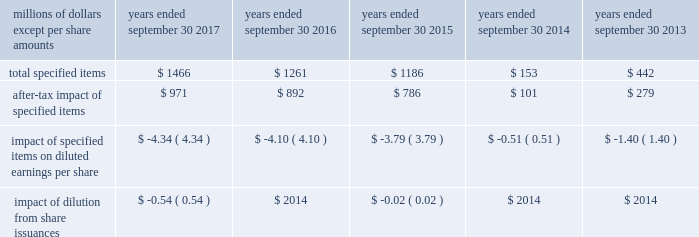( a ) excludes discontinued operations .
( b ) earnings before interest expense and taxes as a percent of average total assets .
( c ) total debt as a percent of the sum of total debt , shareholders 2019 equity and non-current deferred income tax liabilities .
The results above include the impact of the specified items detailed below .
Additional discussion regarding the specified items in fiscal years 2017 , 2016 and 2015 are provided in item 7 .
Management 2019s discussion and analysis of financial condition and results of operations. .
Item 7 .
Management 2019s discussion and analysis of financial condition and results of operations the following commentary should be read in conjunction with the consolidated financial statements and accompanying notes .
Within the tables presented throughout this discussion , certain columns may not add due to the use of rounded numbers for disclosure purposes .
Percentages and earnings per share amounts presented are calculated from the underlying amounts .
References to years throughout this discussion relate to our fiscal years , which end on september 30 .
Company overview description of the company and business segments becton , dickinson and company ( 201cbd 201d ) is a global medical technology company engaged in the development , manufacture and sale of a broad range of medical supplies , devices , laboratory equipment and diagnostic products used by healthcare institutions , life science researchers , clinical laboratories , the pharmaceutical industry and the general public .
The company's organizational structure is based upon two principal business segments , bd medical ( 201cmedical 201d ) and bd life sciences ( 201clife sciences 201d ) .
Bd 2019s products are manufactured and sold worldwide .
Our products are marketed in the united states and internationally through independent distribution channels and directly to end-users by bd and independent sales representatives .
We organize our operations outside the united states as follows : europe ; ema ( which includes the commonwealth of independent states , the middle east and africa ) ; greater asia ( which includes japan and asia pacific ) ; latin america ( which includes mexico , central america , the caribbean , and south america ) ; and canada .
We continue to pursue growth opportunities in emerging markets , which include the following geographic regions : eastern europe , the middle east , africa , latin america and certain countries within asia pacific .
We are primarily focused on certain countries whose healthcare systems are expanding , in particular , china and india .
Strategic objectives bd remains focused on delivering sustainable growth and shareholder value , while making appropriate investments for the future .
Bd management operates the business consistent with the following core strategies : 2022 to increase revenue growth by focusing on our core products , services and solutions that deliver greater benefits to patients , healthcare workers and researchers; .
What is the range of after-tax impact of specified items from 2013-2017 , in millions? 
Computations: (971 - 101)
Answer: 870.0. 